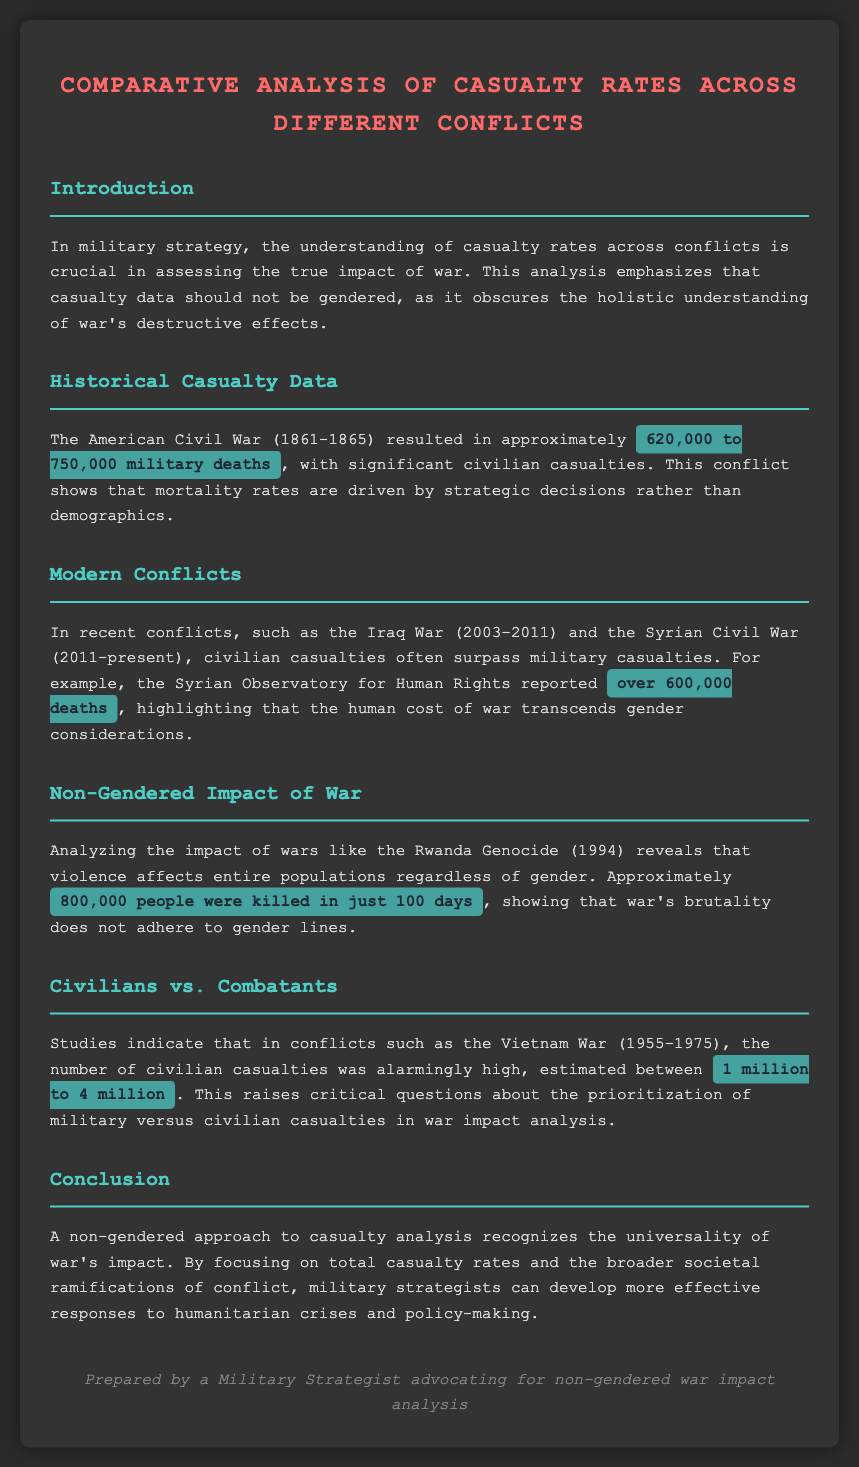What was the casualty range in the American Civil War? The document states that the American Civil War resulted in approximately 620,000 to 750,000 military deaths.
Answer: 620,000 to 750,000 How many deaths were reported in the Syrian Civil War? The document mentions that the Syrian Observatory for Human Rights reported over 600,000 deaths during the Syrian Civil War.
Answer: over 600,000 What was the death toll in the Rwanda Genocide? The document highlights that approximately 800,000 people were killed in just 100 days during the Rwanda Genocide.
Answer: 800,000 What period did the Vietnam War cover? The document indicates that the Vietnam War lasted from 1955 to 1975.
Answer: 1955-1975 What does a non-gendered approach to casualty analysis recognize? The document states that a non-gendered approach to casualty analysis recognizes the universality of war's impact.
Answer: universality of war's impact Why is focusing on total casualty rates important? The document argues that focusing on total casualty rates allows military strategists to develop more effective humanitarian responses.
Answer: develop more effective responses What significant finding is mentioned about civilian casualties in conflicts? The document states that in the Vietnam War, civilian casualties were estimated between 1 million to 4 million.
Answer: 1 million to 4 million What type of casualties often surpass military casualties in recent conflicts? The document notes that civilian casualties often surpass military casualties in recent conflicts.
Answer: civilian casualties 